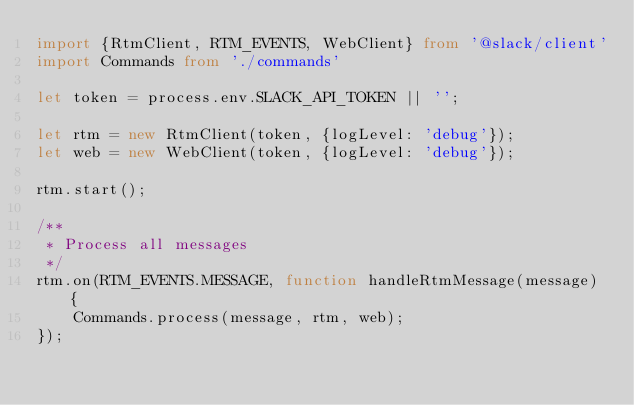<code> <loc_0><loc_0><loc_500><loc_500><_TypeScript_>import {RtmClient, RTM_EVENTS, WebClient} from '@slack/client'
import Commands from './commands'

let token = process.env.SLACK_API_TOKEN || '';

let rtm = new RtmClient(token, {logLevel: 'debug'});
let web = new WebClient(token, {logLevel: 'debug'});

rtm.start();

/**
 * Process all messages
 */
rtm.on(RTM_EVENTS.MESSAGE, function handleRtmMessage(message) {
    Commands.process(message, rtm, web);
});
</code> 